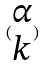<formula> <loc_0><loc_0><loc_500><loc_500>( \begin{matrix} \alpha \\ k \end{matrix} )</formula> 